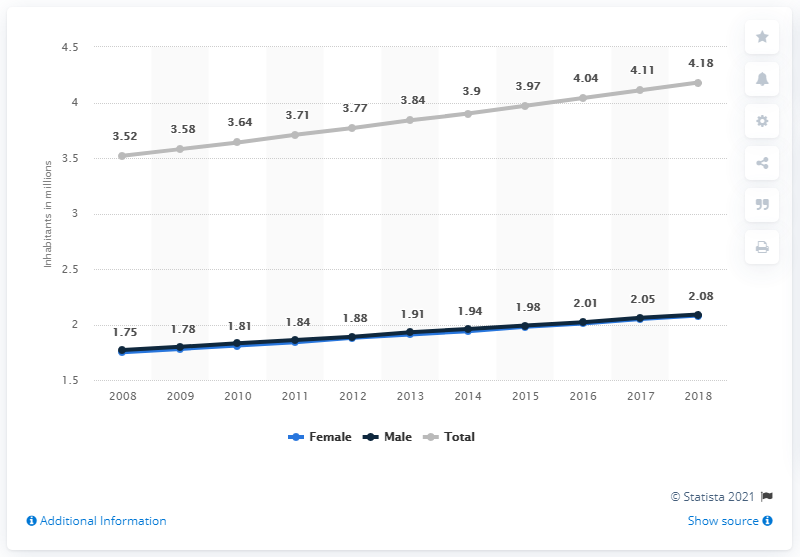Point out several critical features in this image. The male population of Panama in 2018 was 2.08 million. In 2018, the population of Panama was 4.18 million. 